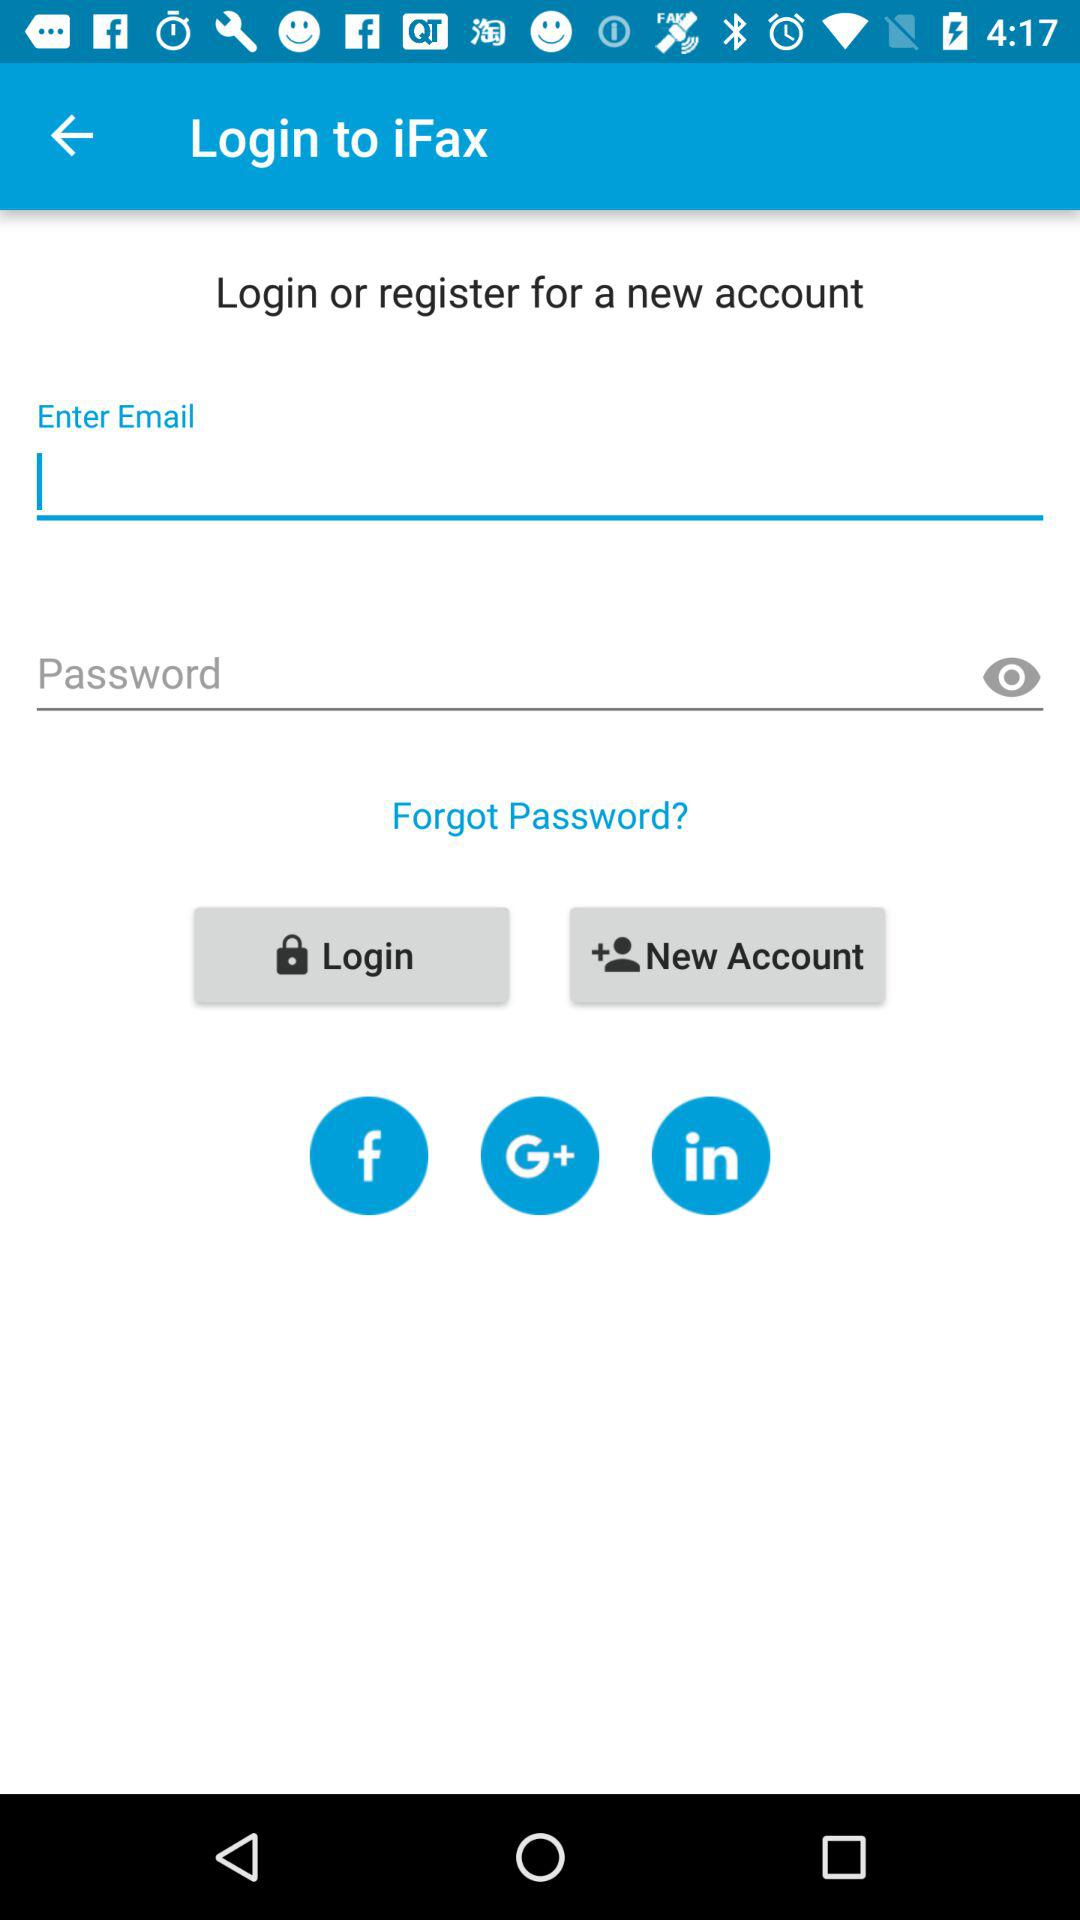What is the application name? The application name is "iFax". 